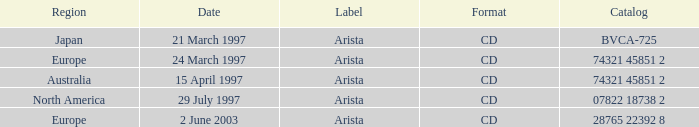Could you help me parse every detail presented in this table? {'header': ['Region', 'Date', 'Label', 'Format', 'Catalog'], 'rows': [['Japan', '21 March 1997', 'Arista', 'CD', 'BVCA-725'], ['Europe', '24 March 1997', 'Arista', 'CD', '74321 45851 2'], ['Australia', '15 April 1997', 'Arista', 'CD', '74321 45851 2'], ['North America', '29 July 1997', 'Arista', 'CD', '07822 18738 2'], ['Europe', '2 June 2003', 'Arista', 'CD', '28765 22392 8']]} What designation does the region of australia have? Arista. 